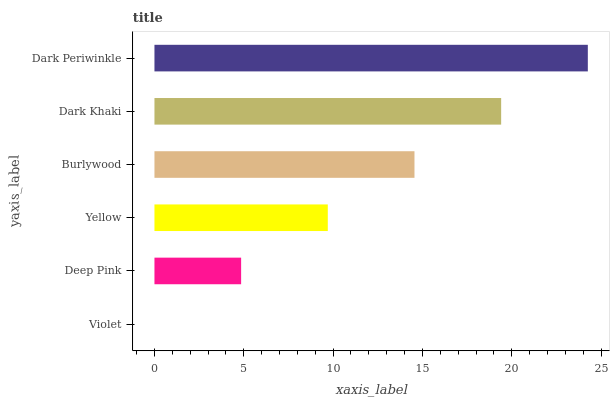Is Violet the minimum?
Answer yes or no. Yes. Is Dark Periwinkle the maximum?
Answer yes or no. Yes. Is Deep Pink the minimum?
Answer yes or no. No. Is Deep Pink the maximum?
Answer yes or no. No. Is Deep Pink greater than Violet?
Answer yes or no. Yes. Is Violet less than Deep Pink?
Answer yes or no. Yes. Is Violet greater than Deep Pink?
Answer yes or no. No. Is Deep Pink less than Violet?
Answer yes or no. No. Is Burlywood the high median?
Answer yes or no. Yes. Is Yellow the low median?
Answer yes or no. Yes. Is Dark Periwinkle the high median?
Answer yes or no. No. Is Dark Khaki the low median?
Answer yes or no. No. 